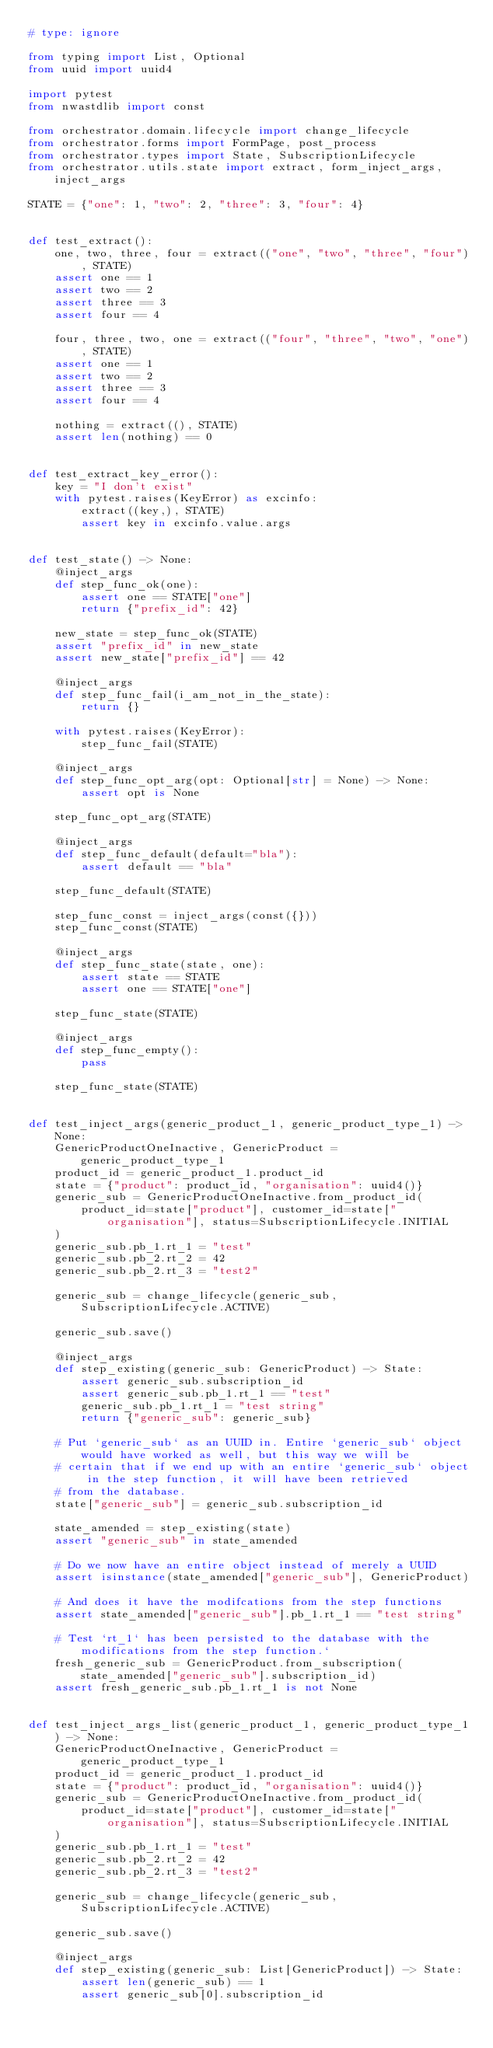Convert code to text. <code><loc_0><loc_0><loc_500><loc_500><_Python_># type: ignore

from typing import List, Optional
from uuid import uuid4

import pytest
from nwastdlib import const

from orchestrator.domain.lifecycle import change_lifecycle
from orchestrator.forms import FormPage, post_process
from orchestrator.types import State, SubscriptionLifecycle
from orchestrator.utils.state import extract, form_inject_args, inject_args

STATE = {"one": 1, "two": 2, "three": 3, "four": 4}


def test_extract():
    one, two, three, four = extract(("one", "two", "three", "four"), STATE)
    assert one == 1
    assert two == 2
    assert three == 3
    assert four == 4

    four, three, two, one = extract(("four", "three", "two", "one"), STATE)
    assert one == 1
    assert two == 2
    assert three == 3
    assert four == 4

    nothing = extract((), STATE)
    assert len(nothing) == 0


def test_extract_key_error():
    key = "I don't exist"
    with pytest.raises(KeyError) as excinfo:
        extract((key,), STATE)
        assert key in excinfo.value.args


def test_state() -> None:
    @inject_args
    def step_func_ok(one):
        assert one == STATE["one"]
        return {"prefix_id": 42}

    new_state = step_func_ok(STATE)
    assert "prefix_id" in new_state
    assert new_state["prefix_id"] == 42

    @inject_args
    def step_func_fail(i_am_not_in_the_state):
        return {}

    with pytest.raises(KeyError):
        step_func_fail(STATE)

    @inject_args
    def step_func_opt_arg(opt: Optional[str] = None) -> None:
        assert opt is None

    step_func_opt_arg(STATE)

    @inject_args
    def step_func_default(default="bla"):
        assert default == "bla"

    step_func_default(STATE)

    step_func_const = inject_args(const({}))
    step_func_const(STATE)

    @inject_args
    def step_func_state(state, one):
        assert state == STATE
        assert one == STATE["one"]

    step_func_state(STATE)

    @inject_args
    def step_func_empty():
        pass

    step_func_state(STATE)


def test_inject_args(generic_product_1, generic_product_type_1) -> None:
    GenericProductOneInactive, GenericProduct = generic_product_type_1
    product_id = generic_product_1.product_id
    state = {"product": product_id, "organisation": uuid4()}
    generic_sub = GenericProductOneInactive.from_product_id(
        product_id=state["product"], customer_id=state["organisation"], status=SubscriptionLifecycle.INITIAL
    )
    generic_sub.pb_1.rt_1 = "test"
    generic_sub.pb_2.rt_2 = 42
    generic_sub.pb_2.rt_3 = "test2"

    generic_sub = change_lifecycle(generic_sub, SubscriptionLifecycle.ACTIVE)

    generic_sub.save()

    @inject_args
    def step_existing(generic_sub: GenericProduct) -> State:
        assert generic_sub.subscription_id
        assert generic_sub.pb_1.rt_1 == "test"
        generic_sub.pb_1.rt_1 = "test string"
        return {"generic_sub": generic_sub}

    # Put `generic_sub` as an UUID in. Entire `generic_sub` object would have worked as well, but this way we will be
    # certain that if we end up with an entire `generic_sub` object in the step function, it will have been retrieved
    # from the database.
    state["generic_sub"] = generic_sub.subscription_id

    state_amended = step_existing(state)
    assert "generic_sub" in state_amended

    # Do we now have an entire object instead of merely a UUID
    assert isinstance(state_amended["generic_sub"], GenericProduct)

    # And does it have the modifcations from the step functions
    assert state_amended["generic_sub"].pb_1.rt_1 == "test string"

    # Test `rt_1` has been persisted to the database with the modifications from the step function.`
    fresh_generic_sub = GenericProduct.from_subscription(state_amended["generic_sub"].subscription_id)
    assert fresh_generic_sub.pb_1.rt_1 is not None


def test_inject_args_list(generic_product_1, generic_product_type_1) -> None:
    GenericProductOneInactive, GenericProduct = generic_product_type_1
    product_id = generic_product_1.product_id
    state = {"product": product_id, "organisation": uuid4()}
    generic_sub = GenericProductOneInactive.from_product_id(
        product_id=state["product"], customer_id=state["organisation"], status=SubscriptionLifecycle.INITIAL
    )
    generic_sub.pb_1.rt_1 = "test"
    generic_sub.pb_2.rt_2 = 42
    generic_sub.pb_2.rt_3 = "test2"

    generic_sub = change_lifecycle(generic_sub, SubscriptionLifecycle.ACTIVE)

    generic_sub.save()

    @inject_args
    def step_existing(generic_sub: List[GenericProduct]) -> State:
        assert len(generic_sub) == 1
        assert generic_sub[0].subscription_id</code> 